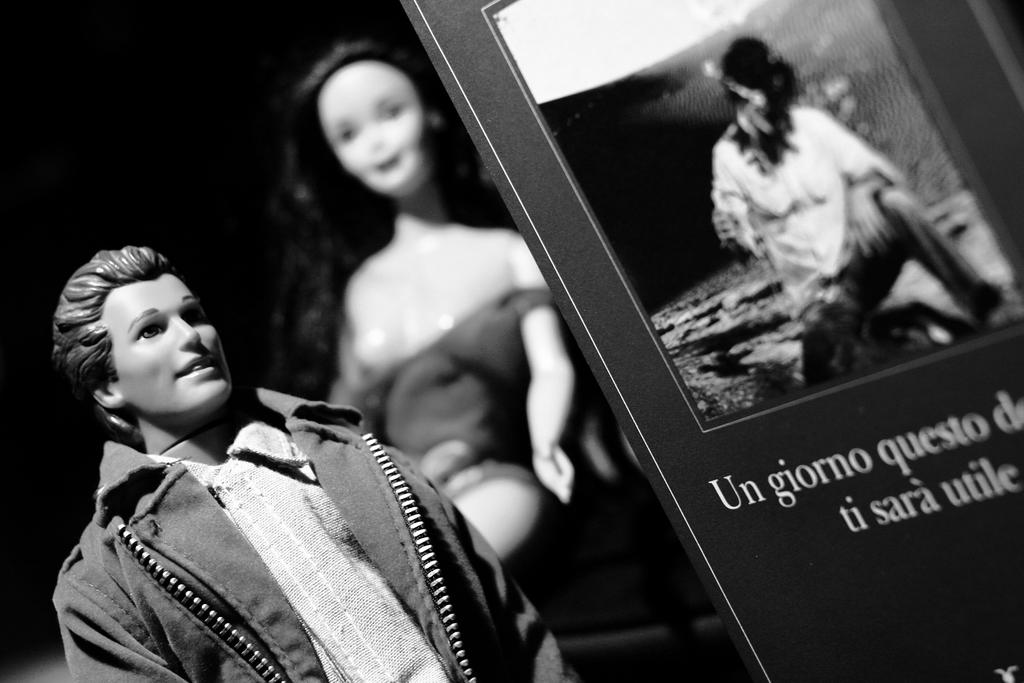What objects can be seen in the image? There are toys in the image. What else is present in the image besides toys? There is a banner in the image. Can you describe the banner in more detail? There is a person depicted on the banner, and there is some matter written on the banner. What type of stamp can be seen on the toys in the image? There is no stamp present on the toys in the image. What kind of meat is being cooked on the range in the image? There is no range or meat present in the image. 